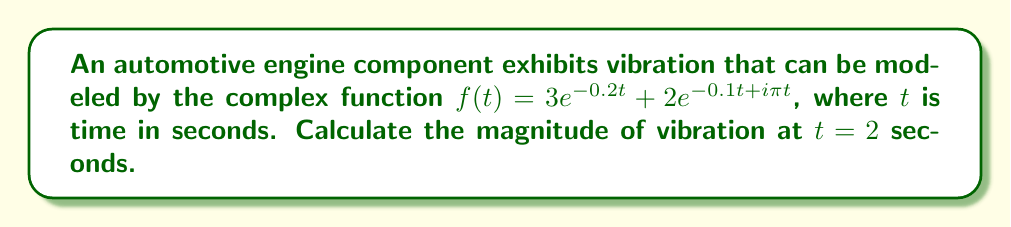Give your solution to this math problem. To solve this problem, we'll follow these steps:

1) The given function is $f(t) = 3e^{-0.2t} + 2e^{-0.1t + i\pi t}$

2) We need to evaluate this at $t = 2$:

   $f(2) = 3e^{-0.2(2)} + 2e^{-0.1(2) + i\pi(2)}$

3) Simplify:
   $f(2) = 3e^{-0.4} + 2e^{-0.2 + 2\pi i}$

4) The first term is real, but the second term is complex. Let's separate them:

   $a = 3e^{-0.4}$ (real part)
   $b = 2e^{-0.2}(\cos(2\pi) + i\sin(2\pi))$ (complex part)

5) Evaluate $a$:
   $a = 3e^{-0.4} \approx 2.01$

6) Evaluate $b$:
   $b = 2e^{-0.2}(\cos(2\pi) + i\sin(2\pi))$
   $= 2e^{-0.2}(1 + 0i)$ (since $\cos(2\pi) = 1$ and $\sin(2\pi) = 0$)
   $= 2e^{-0.2} \approx 1.64$

7) So, $f(2) = 2.01 + 1.64 = 3.65$

8) The magnitude of a complex number is given by $\sqrt{(\text{Re}(z))^2 + (\text{Im}(z))^2}$

9) In this case, $\text{Re}(f(2)) = 3.65$ and $\text{Im}(f(2)) = 0$

10) Therefore, the magnitude is:
    $|f(2)| = \sqrt{3.65^2 + 0^2} = 3.65$
Answer: $3.65$ 